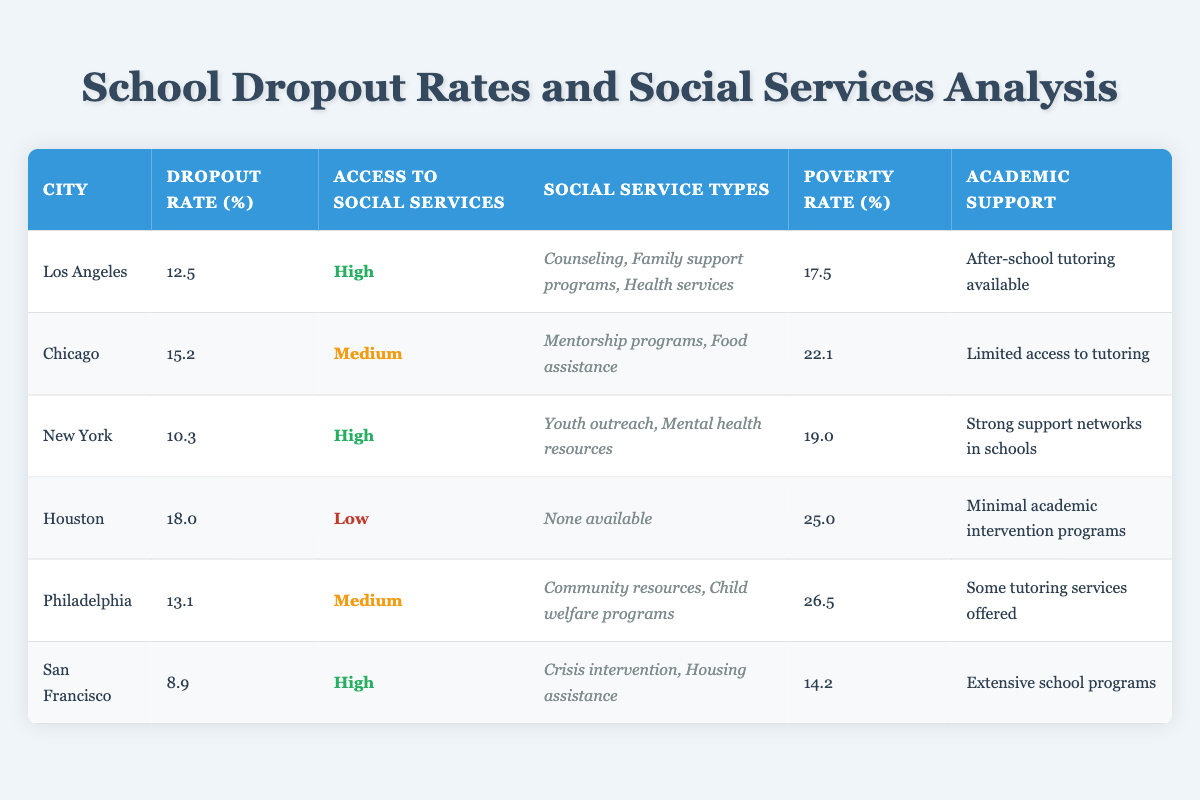What is the dropout rate for San Francisco? The table indicates that San Francisco has a dropout rate of 8.9%. This value is directly listed in the 'Dropout Rate (%)' column for the city.
Answer: 8.9 Which city has the highest poverty rate? By examining the 'Poverty Rate (%)' column for each city, Houston has the highest poverty rate at 25.0%.
Answer: Houston What types of social services are available in Los Angeles? The 'Social Service Types' column for Los Angeles lists three services: Counseling, Family support programs, and Health services.
Answer: Counseling, Family support programs, Health services What is the average dropout rate for cities with high access to social services? The dropout rates for cities with high access to social services are 12.5% (Los Angeles), 10.3% (New York), and 8.9% (San Francisco). To calculate the average: (12.5 + 10.3 + 8.9) / 3 = 10.57%.
Answer: 10.57 Is there a city with low access to social services that has a dropout rate lower than 15%? Houston is the only city with low access to social services, and its dropout rate is 18.0%. Thus, there is no city with low access to social services and a dropout rate below 15%.
Answer: No How many cities have a medium access to social services? The table lists four cities that have medium access to social services: Chicago, Philadelphia, and two more, making a total of three.
Answer: 3 Which city has the lowest dropout rate among the provided data? San Francisco has the lowest dropout rate at 8.9%, compared to other cities listed in the table. This value can be found in the 'Dropout Rate (%)' column for San Francisco.
Answer: San Francisco What is the relationship between poverty rate and dropout rate in Chicago? Chicago has a poverty rate of 22.1% and a dropout rate of 15.2%. The higher poverty rate suggests a potential correlation with the dropout rate, indicating that increased poverty may lead to a higher dropout rate. However, a definitive conclusion would require further analysis.
Answer: Higher poverty may relate to higher dropout rate 